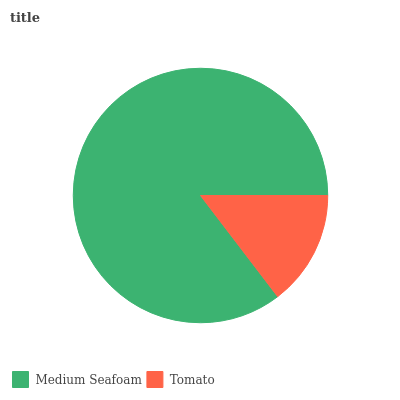Is Tomato the minimum?
Answer yes or no. Yes. Is Medium Seafoam the maximum?
Answer yes or no. Yes. Is Tomato the maximum?
Answer yes or no. No. Is Medium Seafoam greater than Tomato?
Answer yes or no. Yes. Is Tomato less than Medium Seafoam?
Answer yes or no. Yes. Is Tomato greater than Medium Seafoam?
Answer yes or no. No. Is Medium Seafoam less than Tomato?
Answer yes or no. No. Is Medium Seafoam the high median?
Answer yes or no. Yes. Is Tomato the low median?
Answer yes or no. Yes. Is Tomato the high median?
Answer yes or no. No. Is Medium Seafoam the low median?
Answer yes or no. No. 